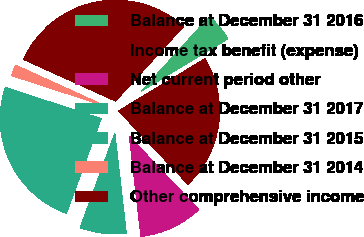Convert chart to OTSL. <chart><loc_0><loc_0><loc_500><loc_500><pie_chart><fcel>Balance at December 31 2016<fcel>Income tax benefit (expense)<fcel>Net current period other<fcel>Balance at December 31 2017<fcel>Balance at December 31 2015<fcel>Balance at December 31 2014<fcel>Other comprehensive income<nl><fcel>4.6%<fcel>21.59%<fcel>10.23%<fcel>7.42%<fcel>24.41%<fcel>1.78%<fcel>29.97%<nl></chart> 